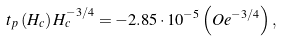<formula> <loc_0><loc_0><loc_500><loc_500>t _ { p } \left ( H _ { c } \right ) H _ { c } ^ { - 3 / 4 } = - 2 . 8 5 \cdot 1 0 ^ { - 5 } \left ( O e ^ { - 3 / 4 } \right ) ,</formula> 